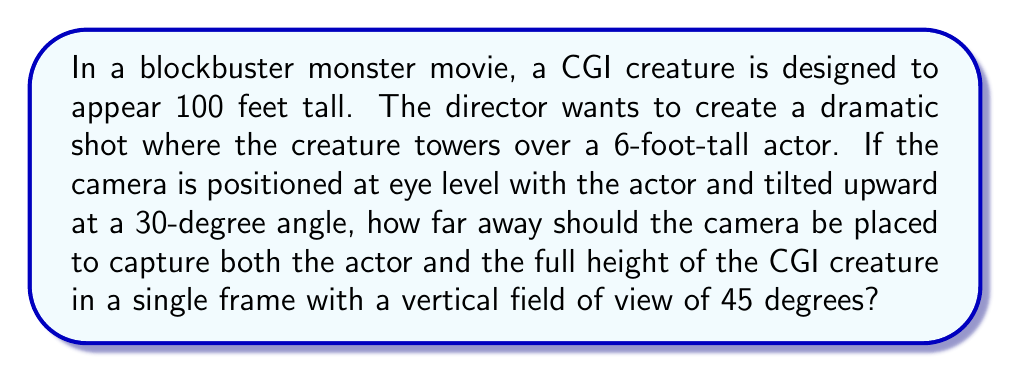Teach me how to tackle this problem. To solve this problem, we'll use some basic trigonometry and the properties of similar triangles. Let's break it down step-by-step:

1. First, we need to calculate the height difference between the top of the CGI creature and the actor:
   $$ H = 100\text{ ft} - 6\text{ ft} = 94\text{ ft} $$

2. Now, let's consider the triangle formed by the camera, the actor, and the top of the CGI creature. We know the angle between the camera and the actor (30°) and the angle of the camera's field of view (45°).

3. The angle between the camera's line of sight to the top of the creature and the horizontal plane is:
   $$ 30° + 45° = 75° $$

4. We can now use the tangent function to find the distance:
   $$ \tan(75°) = \frac{94\text{ ft}}{d} $$
   where $d$ is the distance we're looking for.

5. Rearranging the equation:
   $$ d = \frac{94\text{ ft}}{\tan(75°)} $$

6. Using a calculator or trigonometric tables:
   $$ d \approx 25.19\text{ ft} $$

7. For dramatic effect in filmmaking, we might round this to the nearest foot:
   $$ d \approx 25\text{ ft} $$

This distance will ensure that both the actor and the full height of the CGI creature are captured in the frame, creating a visually striking shot that emphasizes the creature's massive scale.
Answer: The camera should be placed approximately 25 feet away from the actor and CGI creature. 